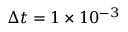Convert formula to latex. <formula><loc_0><loc_0><loc_500><loc_500>\Delta t = 1 \times 1 0 ^ { - 3 }</formula> 